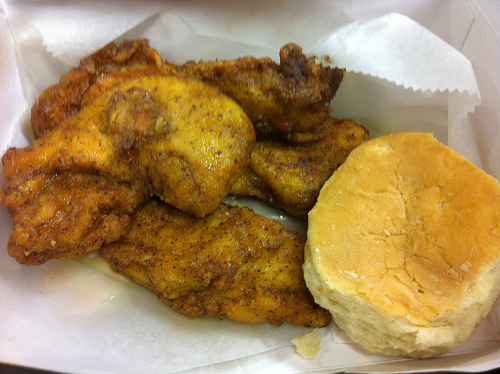<image>
Can you confirm if the meat is on the meat? Yes. Looking at the image, I can see the meat is positioned on top of the meat, with the meat providing support. Where is the biscuit in relation to the wrapping paper? Is it on the wrapping paper? Yes. Looking at the image, I can see the biscuit is positioned on top of the wrapping paper, with the wrapping paper providing support. 